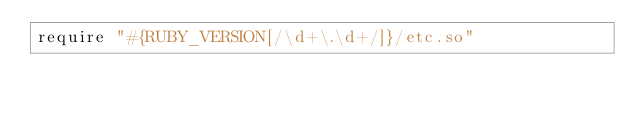<code> <loc_0><loc_0><loc_500><loc_500><_Ruby_>require "#{RUBY_VERSION[/\d+\.\d+/]}/etc.so"
</code> 